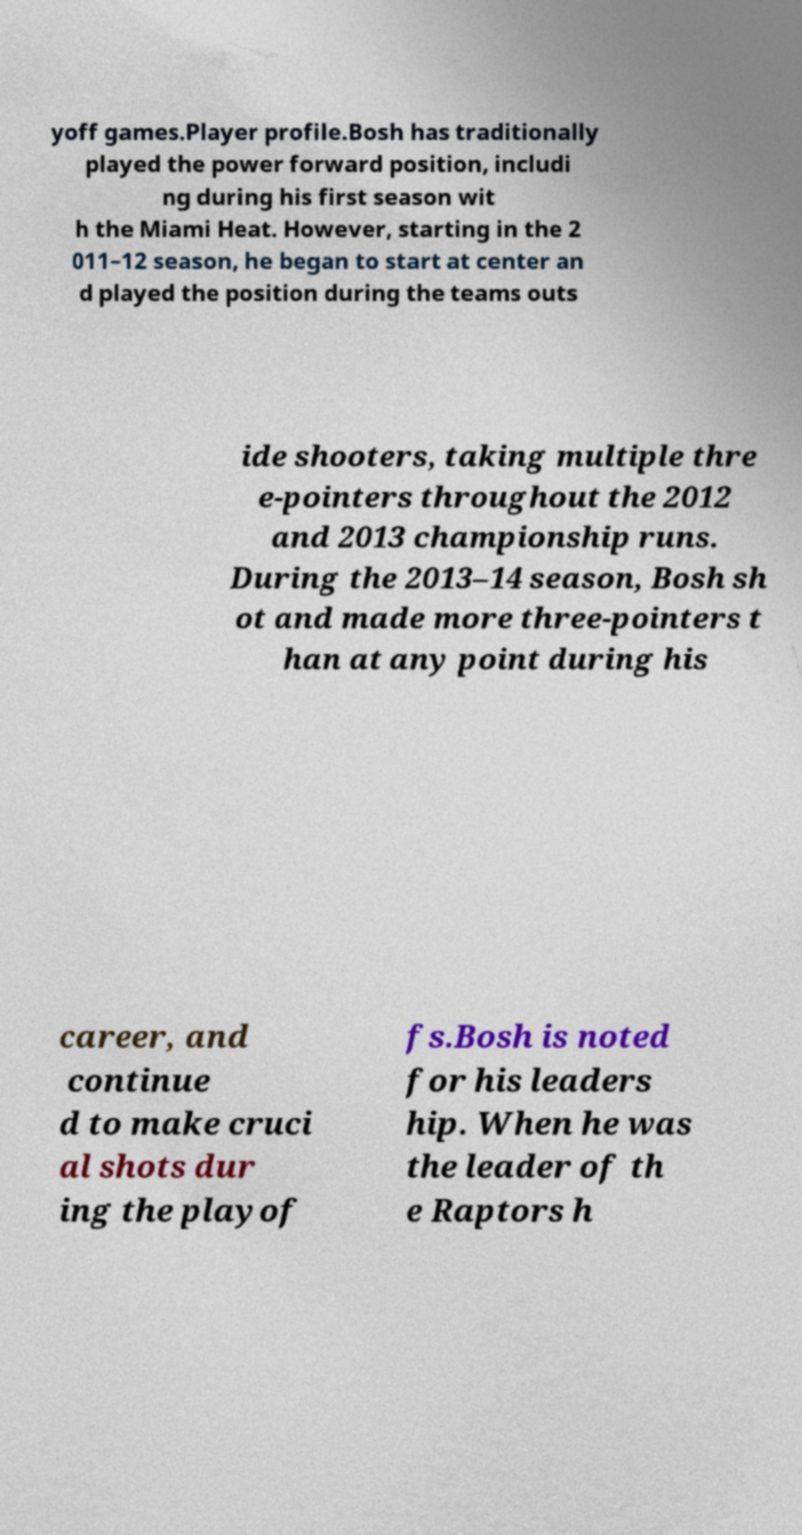Could you extract and type out the text from this image? yoff games.Player profile.Bosh has traditionally played the power forward position, includi ng during his first season wit h the Miami Heat. However, starting in the 2 011–12 season, he began to start at center an d played the position during the teams outs ide shooters, taking multiple thre e-pointers throughout the 2012 and 2013 championship runs. During the 2013–14 season, Bosh sh ot and made more three-pointers t han at any point during his career, and continue d to make cruci al shots dur ing the playof fs.Bosh is noted for his leaders hip. When he was the leader of th e Raptors h 